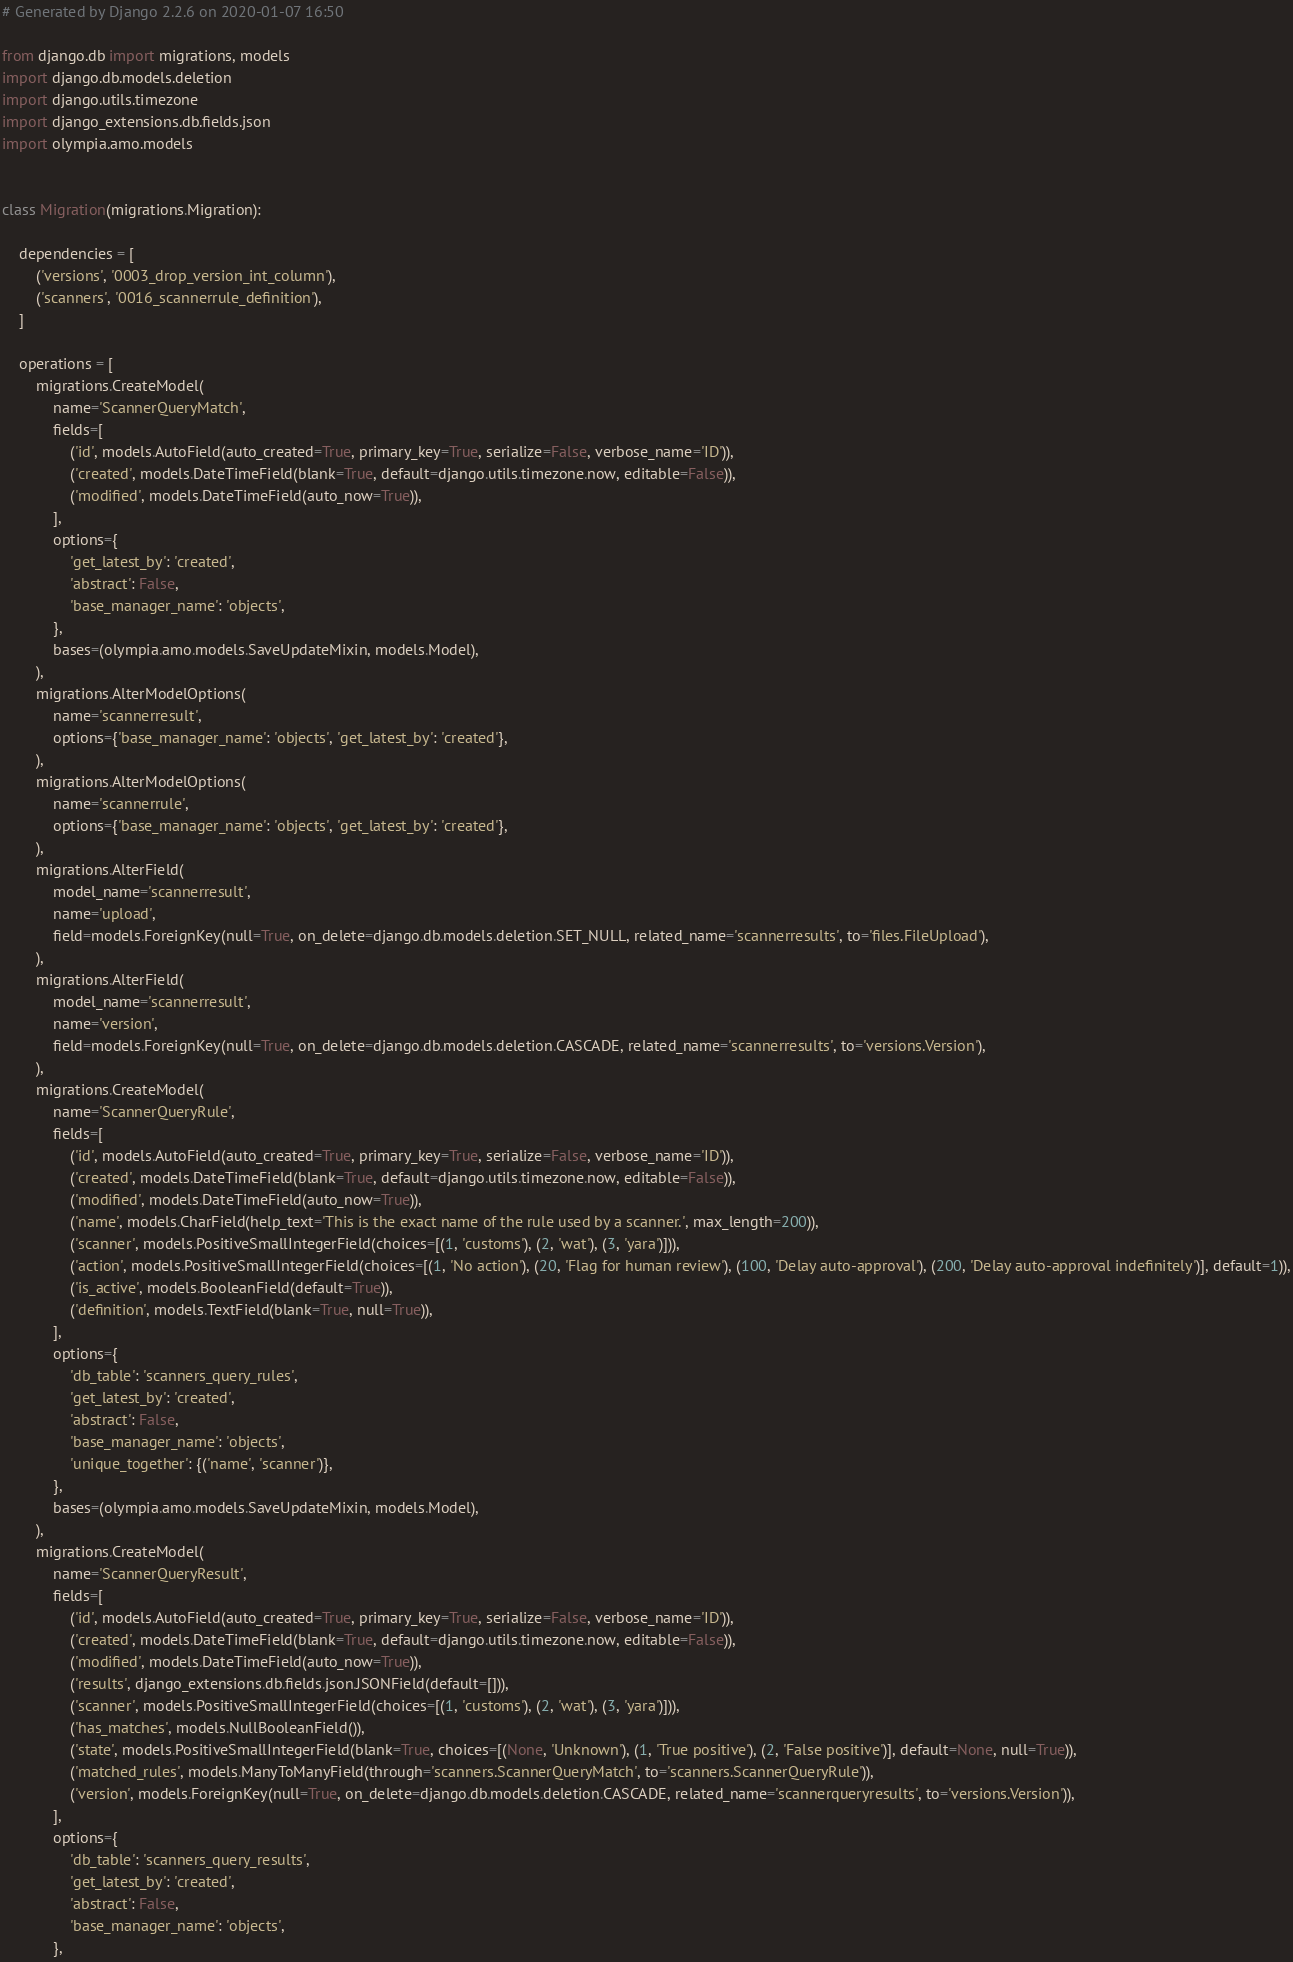Convert code to text. <code><loc_0><loc_0><loc_500><loc_500><_Python_># Generated by Django 2.2.6 on 2020-01-07 16:50

from django.db import migrations, models
import django.db.models.deletion
import django.utils.timezone
import django_extensions.db.fields.json
import olympia.amo.models


class Migration(migrations.Migration):

    dependencies = [
        ('versions', '0003_drop_version_int_column'),
        ('scanners', '0016_scannerrule_definition'),
    ]

    operations = [
        migrations.CreateModel(
            name='ScannerQueryMatch',
            fields=[
                ('id', models.AutoField(auto_created=True, primary_key=True, serialize=False, verbose_name='ID')),
                ('created', models.DateTimeField(blank=True, default=django.utils.timezone.now, editable=False)),
                ('modified', models.DateTimeField(auto_now=True)),
            ],
            options={
                'get_latest_by': 'created',
                'abstract': False,
                'base_manager_name': 'objects',
            },
            bases=(olympia.amo.models.SaveUpdateMixin, models.Model),
        ),
        migrations.AlterModelOptions(
            name='scannerresult',
            options={'base_manager_name': 'objects', 'get_latest_by': 'created'},
        ),
        migrations.AlterModelOptions(
            name='scannerrule',
            options={'base_manager_name': 'objects', 'get_latest_by': 'created'},
        ),
        migrations.AlterField(
            model_name='scannerresult',
            name='upload',
            field=models.ForeignKey(null=True, on_delete=django.db.models.deletion.SET_NULL, related_name='scannerresults', to='files.FileUpload'),
        ),
        migrations.AlterField(
            model_name='scannerresult',
            name='version',
            field=models.ForeignKey(null=True, on_delete=django.db.models.deletion.CASCADE, related_name='scannerresults', to='versions.Version'),
        ),
        migrations.CreateModel(
            name='ScannerQueryRule',
            fields=[
                ('id', models.AutoField(auto_created=True, primary_key=True, serialize=False, verbose_name='ID')),
                ('created', models.DateTimeField(blank=True, default=django.utils.timezone.now, editable=False)),
                ('modified', models.DateTimeField(auto_now=True)),
                ('name', models.CharField(help_text='This is the exact name of the rule used by a scanner.', max_length=200)),
                ('scanner', models.PositiveSmallIntegerField(choices=[(1, 'customs'), (2, 'wat'), (3, 'yara')])),
                ('action', models.PositiveSmallIntegerField(choices=[(1, 'No action'), (20, 'Flag for human review'), (100, 'Delay auto-approval'), (200, 'Delay auto-approval indefinitely')], default=1)),
                ('is_active', models.BooleanField(default=True)),
                ('definition', models.TextField(blank=True, null=True)),
            ],
            options={
                'db_table': 'scanners_query_rules',
                'get_latest_by': 'created',
                'abstract': False,
                'base_manager_name': 'objects',
                'unique_together': {('name', 'scanner')},
            },
            bases=(olympia.amo.models.SaveUpdateMixin, models.Model),
        ),
        migrations.CreateModel(
            name='ScannerQueryResult',
            fields=[
                ('id', models.AutoField(auto_created=True, primary_key=True, serialize=False, verbose_name='ID')),
                ('created', models.DateTimeField(blank=True, default=django.utils.timezone.now, editable=False)),
                ('modified', models.DateTimeField(auto_now=True)),
                ('results', django_extensions.db.fields.json.JSONField(default=[])),
                ('scanner', models.PositiveSmallIntegerField(choices=[(1, 'customs'), (2, 'wat'), (3, 'yara')])),
                ('has_matches', models.NullBooleanField()),
                ('state', models.PositiveSmallIntegerField(blank=True, choices=[(None, 'Unknown'), (1, 'True positive'), (2, 'False positive')], default=None, null=True)),
                ('matched_rules', models.ManyToManyField(through='scanners.ScannerQueryMatch', to='scanners.ScannerQueryRule')),
                ('version', models.ForeignKey(null=True, on_delete=django.db.models.deletion.CASCADE, related_name='scannerqueryresults', to='versions.Version')),
            ],
            options={
                'db_table': 'scanners_query_results',
                'get_latest_by': 'created',
                'abstract': False,
                'base_manager_name': 'objects',
            },</code> 